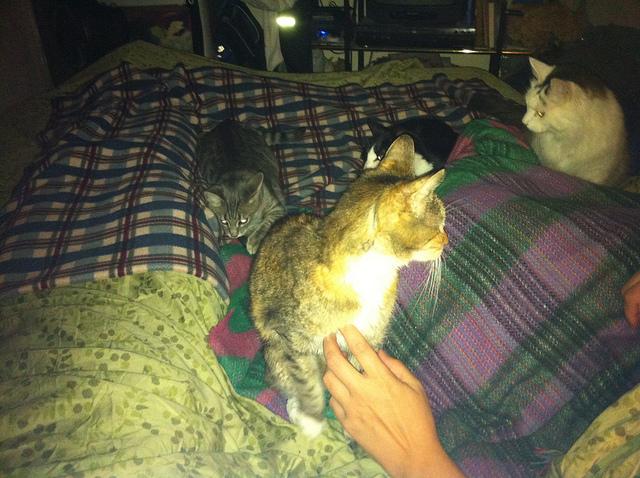Are the cats in bed?
Concise answer only. Yes. Are all cats of the same breed?
Be succinct. No. How many cats are on the bed?
Answer briefly. 4. 